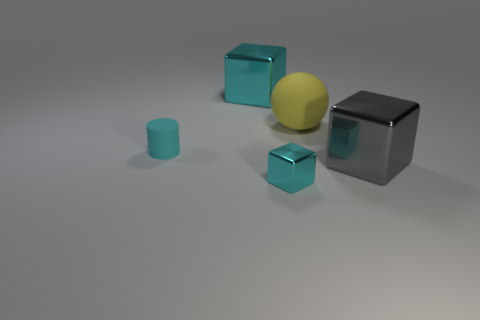Is the block that is behind the large yellow thing made of the same material as the gray thing?
Your response must be concise. Yes. Is there anything else that has the same material as the small cyan cylinder?
Your answer should be compact. Yes. How big is the rubber thing that is behind the cylinder that is in front of the big cyan block?
Keep it short and to the point. Large. What size is the cyan metallic object in front of the metal block that is behind the large cube to the right of the tiny metal block?
Provide a short and direct response. Small. Do the large shiny thing that is left of the small cyan metallic cube and the rubber thing left of the big cyan thing have the same shape?
Offer a very short reply. No. How many other objects are the same color as the tiny matte object?
Provide a short and direct response. 2. Does the rubber object that is to the right of the cyan rubber thing have the same size as the matte cylinder?
Keep it short and to the point. No. Is the cyan thing that is in front of the gray object made of the same material as the large object that is on the left side of the large yellow matte object?
Your response must be concise. Yes. Is there a cyan metallic cube of the same size as the cyan cylinder?
Make the answer very short. Yes. There is a large metallic object that is in front of the cyan metallic block left of the cyan shiny block in front of the big gray block; what is its shape?
Your answer should be very brief. Cube. 